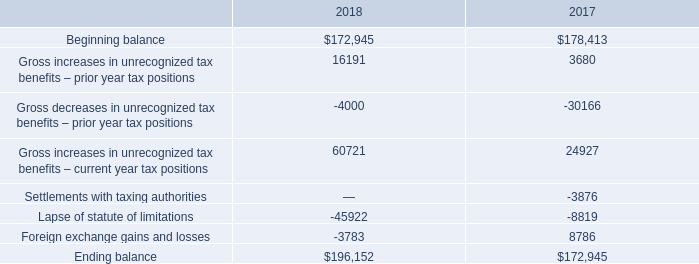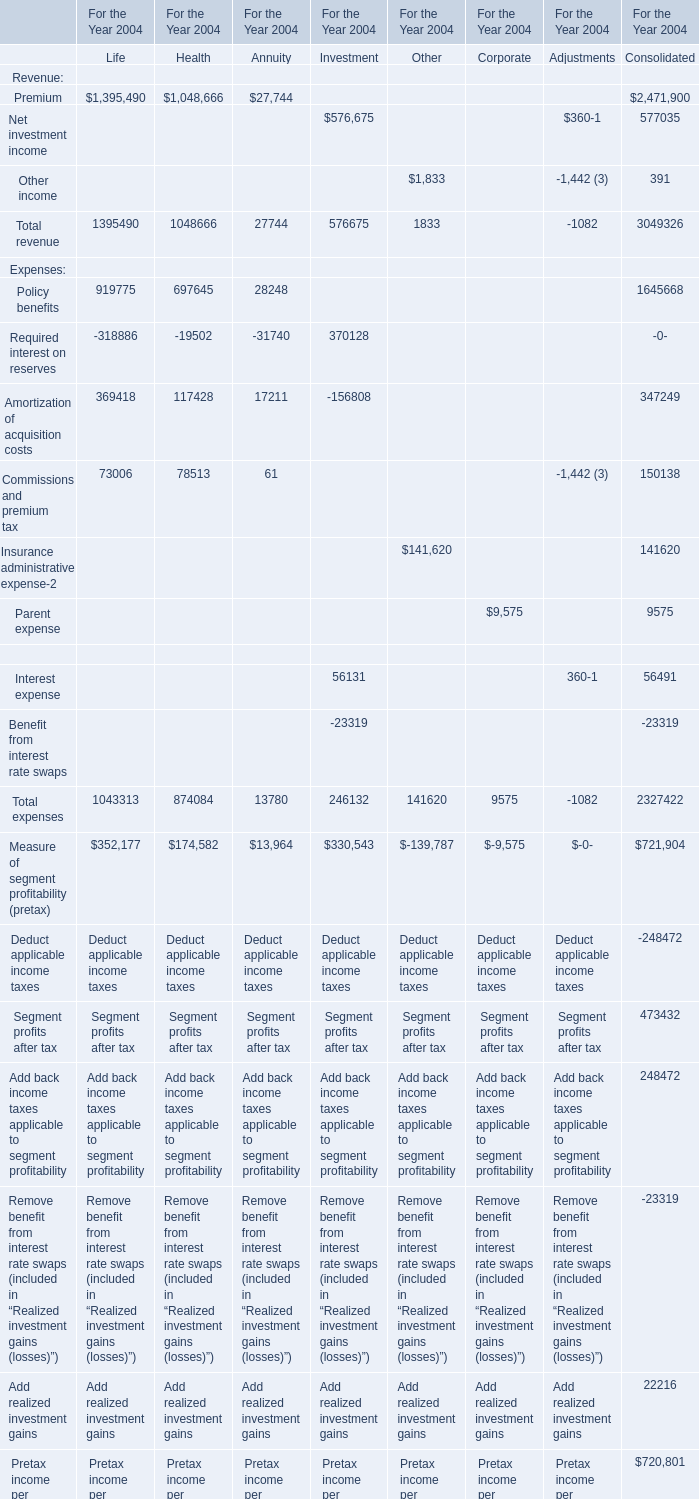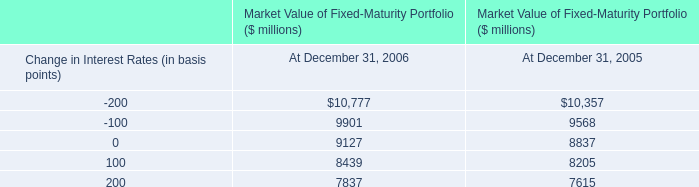For the section with the most Total revenue in 2004 between Life,Health and Annuity, what is the value of the Amortization of acquisition costs in 2004? 
Answer: 369418. 